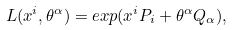Convert formula to latex. <formula><loc_0><loc_0><loc_500><loc_500>L ( x ^ { i } , \theta ^ { \alpha } ) = e x p ( x ^ { i } P _ { i } + \theta ^ { \alpha } Q _ { \alpha } ) ,</formula> 